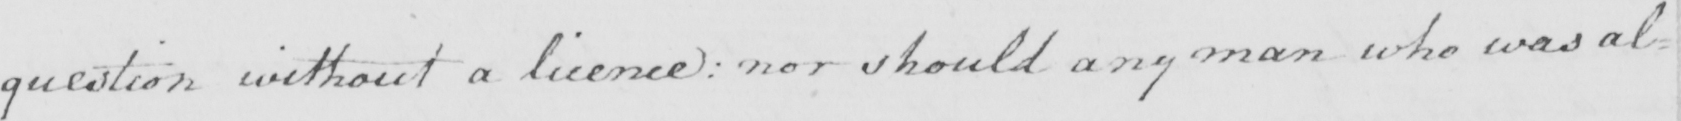Please provide the text content of this handwritten line. question without a licence :  nor should any man who was al= 